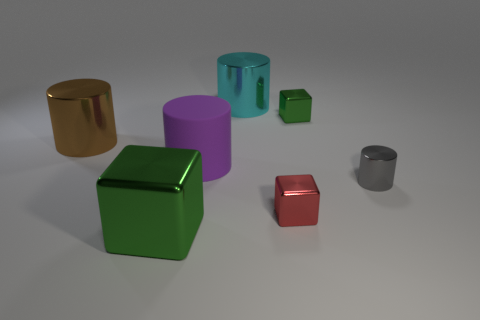If we were to categorize these objects by size, how would you group them? Based on their size, the objects in the image could be grouped into three categories: large, medium, and small. The large objects include the gold and purple cylinders, and the medium objects comprise the teal cylinder and the green cube. Lastly, the small objects are the red cube and the silver cylinder. 